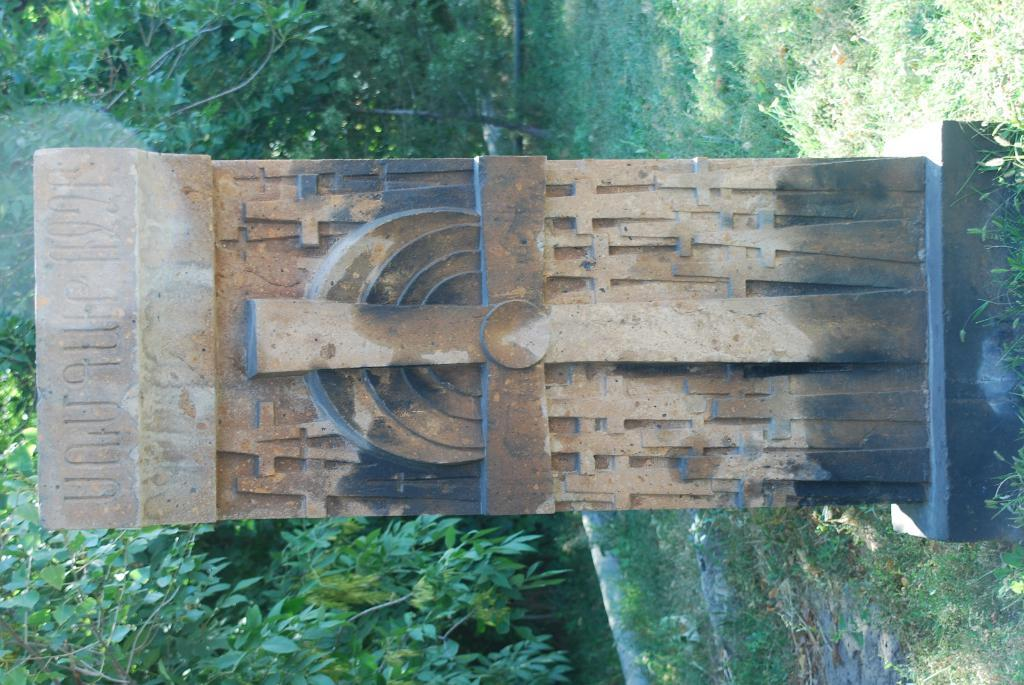What can be seen on the wall in the image? There are sculptures of the cross and other designs on a wall in the image. What is the wall a part of? The wall is part of a grave. What type of vegetation is visible in the background of the image? There are trees in the background of the image. What is the ground covered with in the image? There is grass on the ground in the image. What type of knowledge is being shared in the image? There is no indication of knowledge being shared in the image; it primarily features a wall with sculptures and the surrounding environment. 